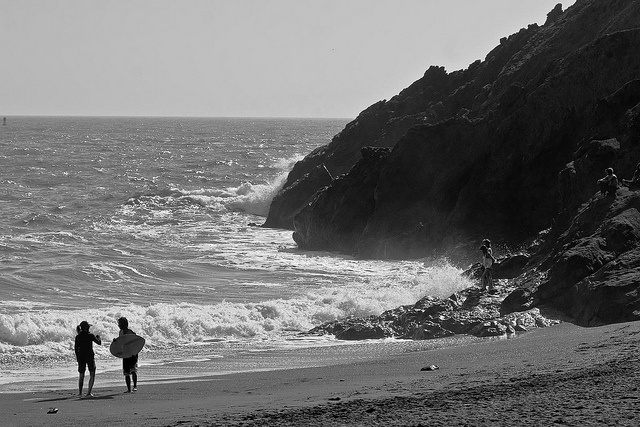Describe the objects in this image and their specific colors. I can see people in darkgray, black, gray, and lightgray tones, people in darkgray, black, gray, and lightgray tones, surfboard in darkgray, black, gray, and lightgray tones, people in darkgray, black, gray, and lightgray tones, and people in black, gray, and darkgray tones in this image. 